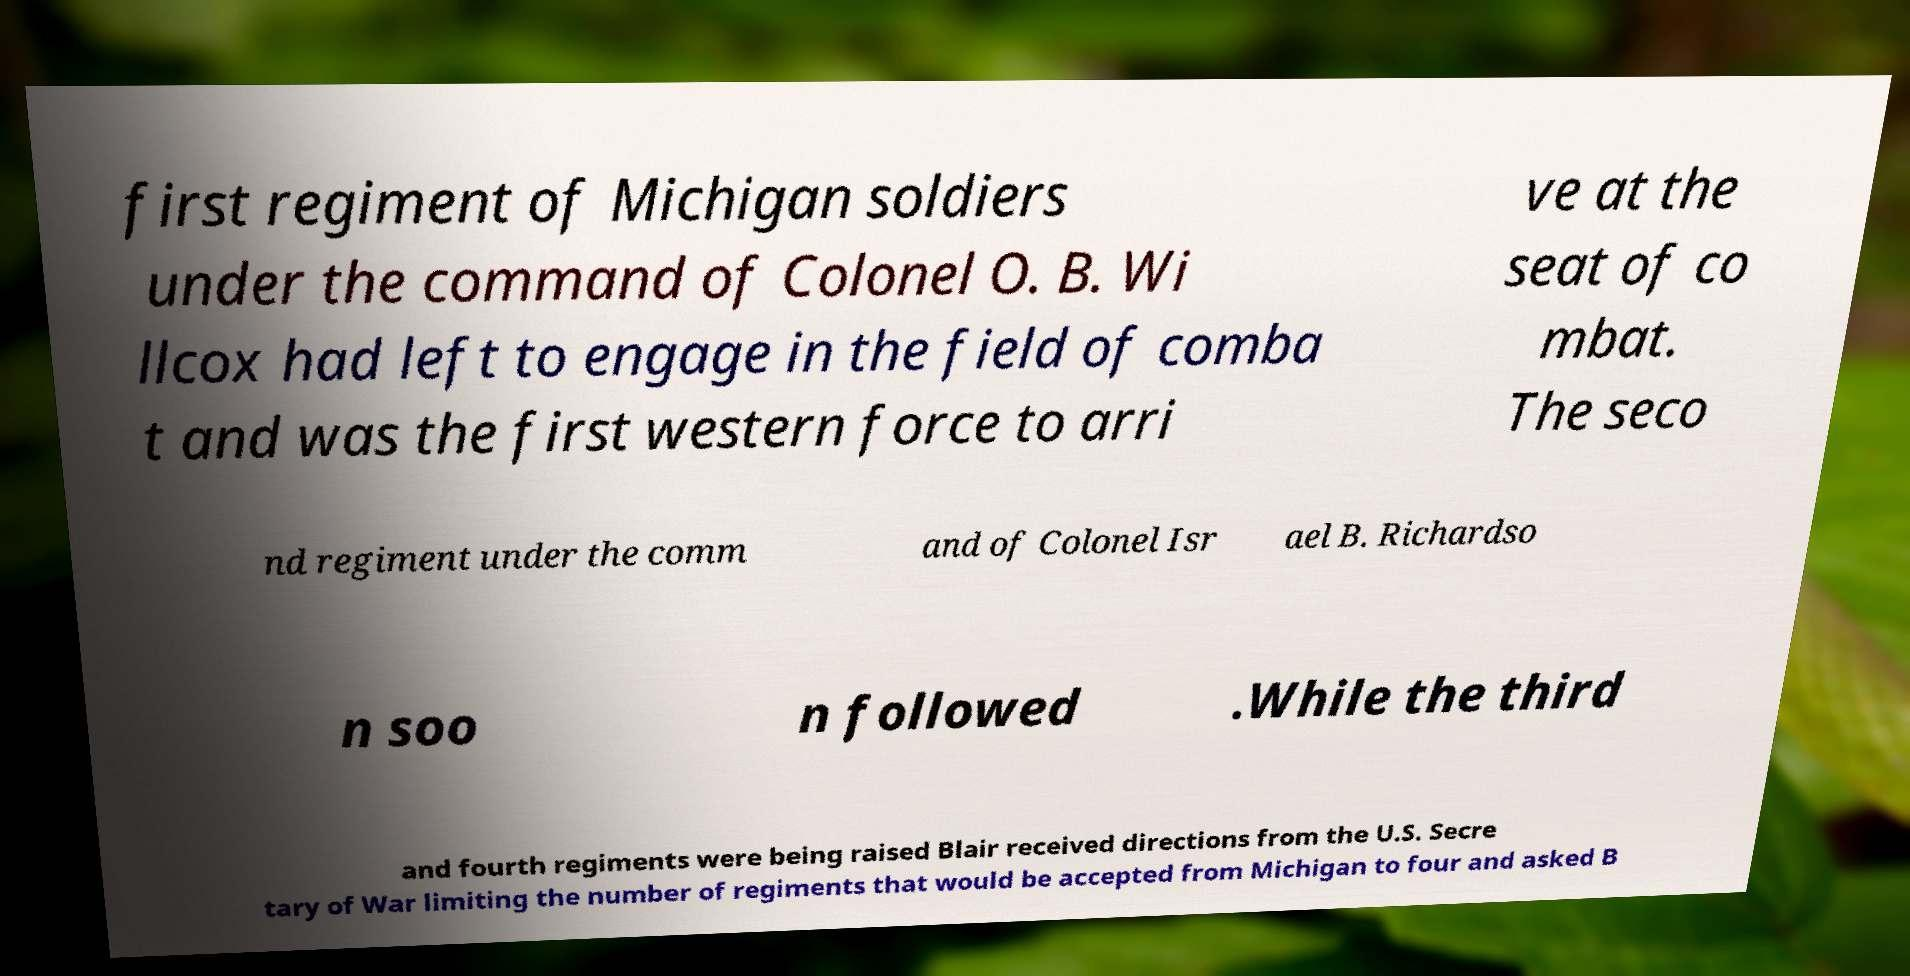For documentation purposes, I need the text within this image transcribed. Could you provide that? first regiment of Michigan soldiers under the command of Colonel O. B. Wi llcox had left to engage in the field of comba t and was the first western force to arri ve at the seat of co mbat. The seco nd regiment under the comm and of Colonel Isr ael B. Richardso n soo n followed .While the third and fourth regiments were being raised Blair received directions from the U.S. Secre tary of War limiting the number of regiments that would be accepted from Michigan to four and asked B 